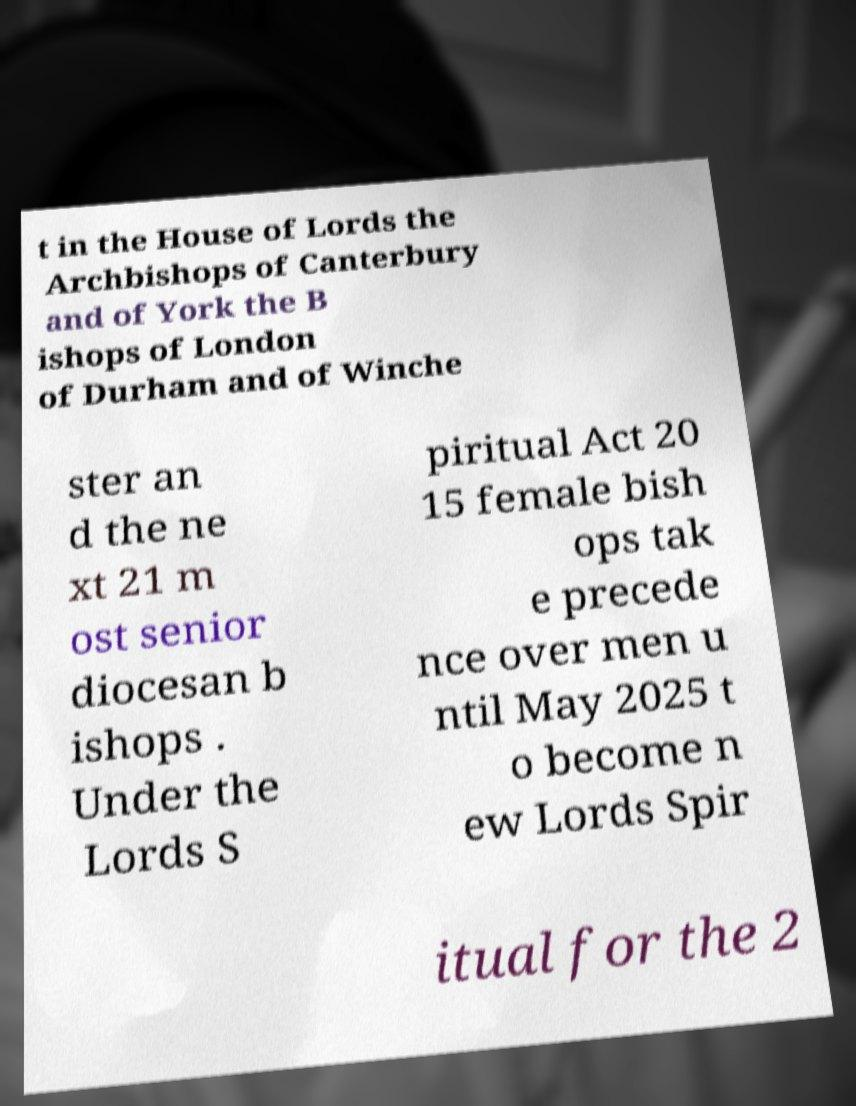Please identify and transcribe the text found in this image. t in the House of Lords the Archbishops of Canterbury and of York the B ishops of London of Durham and of Winche ster an d the ne xt 21 m ost senior diocesan b ishops . Under the Lords S piritual Act 20 15 female bish ops tak e precede nce over men u ntil May 2025 t o become n ew Lords Spir itual for the 2 